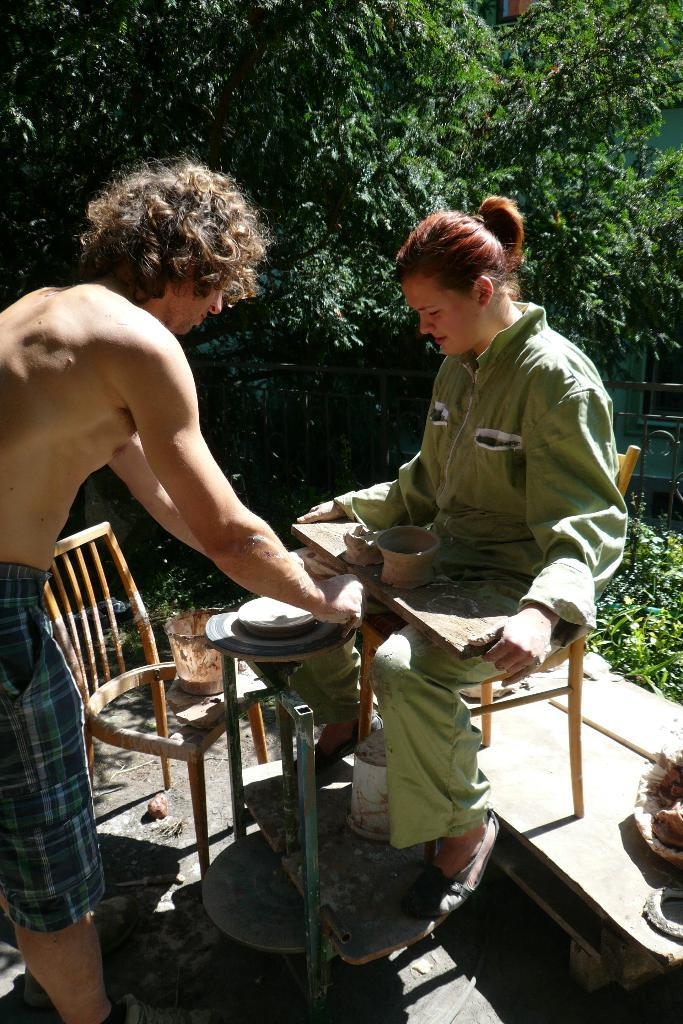What is the woman doing in the image? The woman is sitting on a chair in the image. What is the man doing in the image? The man is standing on the floor in the image. What object can be seen in the image besides the people? There is a bucket in the image. What can be seen in the distance in the image? Trees are visible in the background of the image. What type of chain can be seen hanging from the woman's neck in the image? There is no chain visible in the image; the woman is not wearing any jewelry. What type of teeth can be seen in the image? There are no teeth visible in the image, as it features people and a bucket in a setting with trees in the background. 